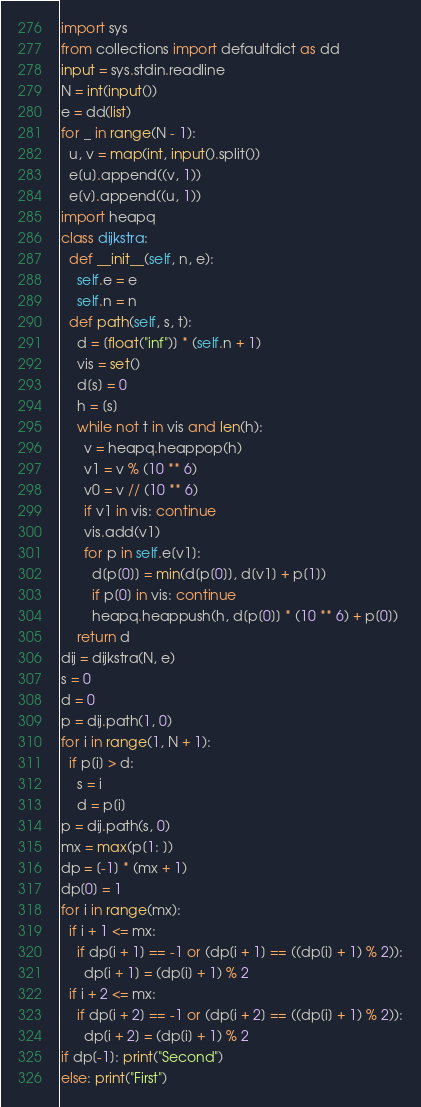<code> <loc_0><loc_0><loc_500><loc_500><_Python_>import sys
from collections import defaultdict as dd
input = sys.stdin.readline
N = int(input())
e = dd(list)
for _ in range(N - 1):
  u, v = map(int, input().split())
  e[u].append((v, 1))
  e[v].append((u, 1))
import heapq
class dijkstra:
  def __init__(self, n, e):
    self.e = e
    self.n = n
  def path(self, s, t):
    d = [float("inf")] * (self.n + 1)
    vis = set()
    d[s] = 0
    h = [s]
    while not t in vis and len(h):
      v = heapq.heappop(h)
      v1 = v % (10 ** 6)
      v0 = v // (10 ** 6)
      if v1 in vis: continue
      vis.add(v1)
      for p in self.e[v1]:
        d[p[0]] = min(d[p[0]], d[v1] + p[1])
        if p[0] in vis: continue
        heapq.heappush(h, d[p[0]] * (10 ** 6) + p[0])
    return d
dij = dijkstra(N, e)
s = 0
d = 0
p = dij.path(1, 0)
for i in range(1, N + 1):
  if p[i] > d:
    s = i
    d = p[i]
p = dij.path(s, 0)
mx = max(p[1: ])
dp = [-1] * (mx + 1)
dp[0] = 1
for i in range(mx):
  if i + 1 <= mx:
    if dp[i + 1] == -1 or (dp[i + 1] == ((dp[i] + 1) % 2)):
      dp[i + 1] = (dp[i] + 1) % 2
  if i + 2 <= mx:
    if dp[i + 2] == -1 or (dp[i + 2] == ((dp[i] + 1) % 2)):
      dp[i + 2] = (dp[i] + 1) % 2
if dp[-1]: print("Second")
else: print("First")</code> 